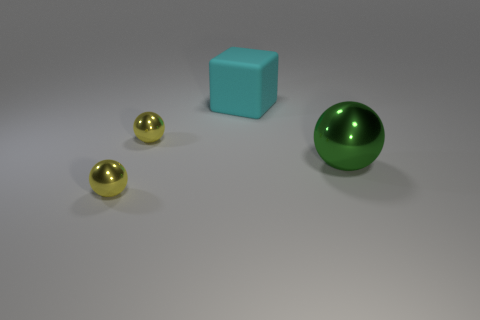What can you infer about the lighting in this scene? The shadows cast by the objects are soft and diffused, suggesting the presence of indirect or ambient lighting. The light source appears to be above and to the left of the scene, based on the direction of the shadows. 